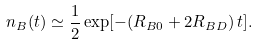Convert formula to latex. <formula><loc_0><loc_0><loc_500><loc_500>n _ { B } ( t ) \simeq \frac { 1 } { 2 } \exp [ - ( R _ { B 0 } + 2 R _ { B D } ) \, t ] .</formula> 